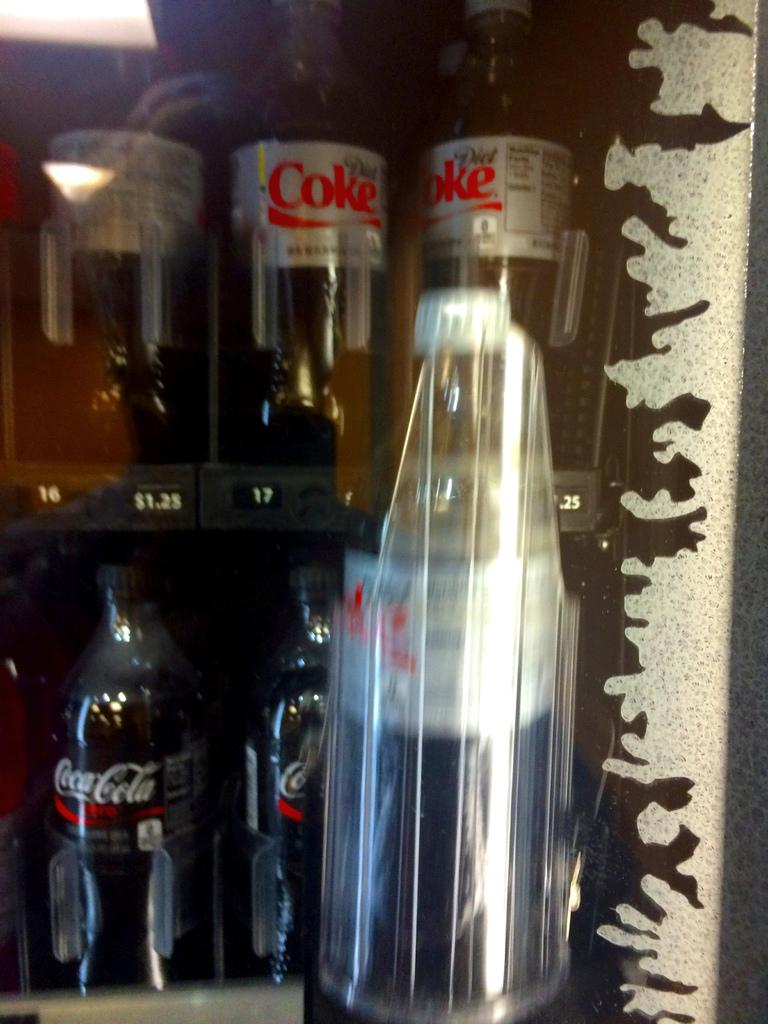<image>
Share a concise interpretation of the image provided. Several Coca Cola bottles are behind a clear bottle. 